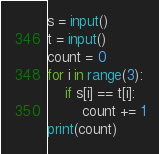<code> <loc_0><loc_0><loc_500><loc_500><_Python_>s = input()
t = input()
count = 0
for i in range(3):
    if s[i] == t[i]:
        count += 1
print(count)</code> 